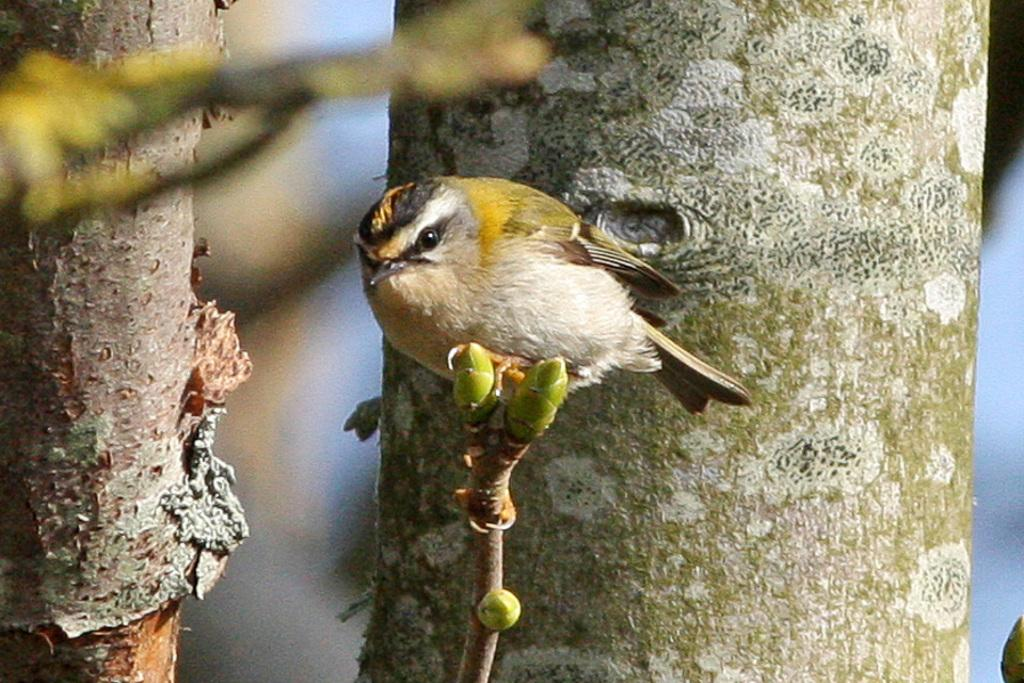What type of animal can be seen in the image? There is a bird in the image. Where is the bird located in the image? The bird is sitting on a stem. What can be seen in the background of the image? There are barks of trees in the background of the image. What type of calculator is the bird wearing around its neck in the image? There is no calculator or collar present in the image; it features a bird sitting on a stem with tree barks in the background. 